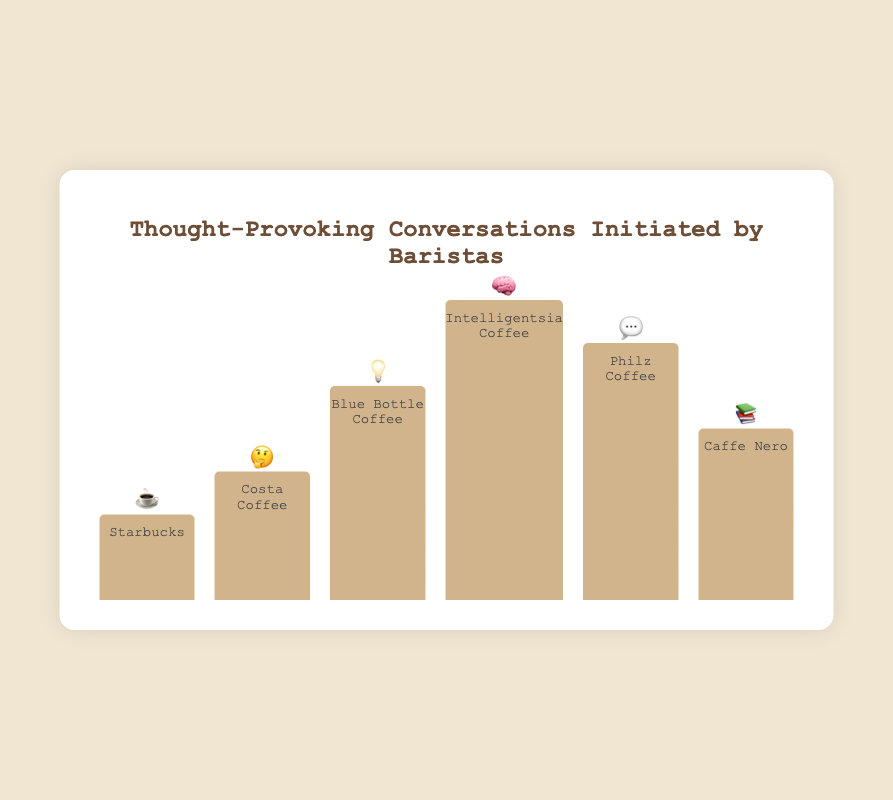what's the title of the chart? The title of the chart is written at the top and aligned in the center. It uses larger, bold font compared to the rest of the text in the chart.
Answer: Thought-Provoking Conversations Initiated by Baristas how many café chains are represented in the chart? You can count the number of distinct bars in the chart, each corresponding to a different café chain.
Answer: 6 which café chain has the highest frequency of thought-provoking conversations? By comparing the heights of all bars, the tallest one indicates the highest frequency of thought-provoking conversations.
Answer: Intelligentsia Coffee what emoji is associated with Blue Bottle Coffee? The emoji is displayed at the top of the bar corresponding to Blue Bottle Coffee.
Answer: 💡 what’s the difference in thought-provoking conversations between Costa Coffee and Philz Coffee? Subtract the number of thought-provoking conversations of Costa Coffee (3) from Philz Coffee (6).
Answer: 3 what is the total frequency of thought-provoking conversations across all café chains? Sum all the values for thought-provoking conversations across each café chain: 2 (Starbucks) + 3 (Costa Coffee) + 5 (Blue Bottle Coffee) + 7 (Intelligentsia Coffee) + 6 (Philz Coffee) + 4 (Caffe Nero).
Answer: 27 which chain has a higher frequency of thought-provoking conversations, Costa Coffee or Caffe Nero? Compare the heights of the bars for Costa Coffee and Caffe Nero or their corresponding values.
Answer: Caffe Nero what's the average frequency of thought-provoking conversations across all café chains? First, calculate the total frequency (27 conversations), then divide by the number of café chains (6).
Answer: 4.5 Arrange the café chains in ascending order based on the frequency of thought-provoking conversations. List the café chains from the smallest to the largest based on their conversation frequency values: 2 (Starbucks), 3 (Costa Coffee), 4 (Caffe Nero), 5 (Blue Bottle Coffee), 6 (Philz Coffee), 7 (Intelligentsia Coffee).
Answer: Starbucks, Costa Coffee, Caffe Nero, Blue Bottle Coffee, Philz Coffee, Intelligentsia Coffee how much higher is the frequency of thought-provoking conversations at Intelligentsia Coffee compared to Starbucks? Subtract the frequency of Starbucks (2) from Intelligentsia Coffee (7).
Answer: 5 